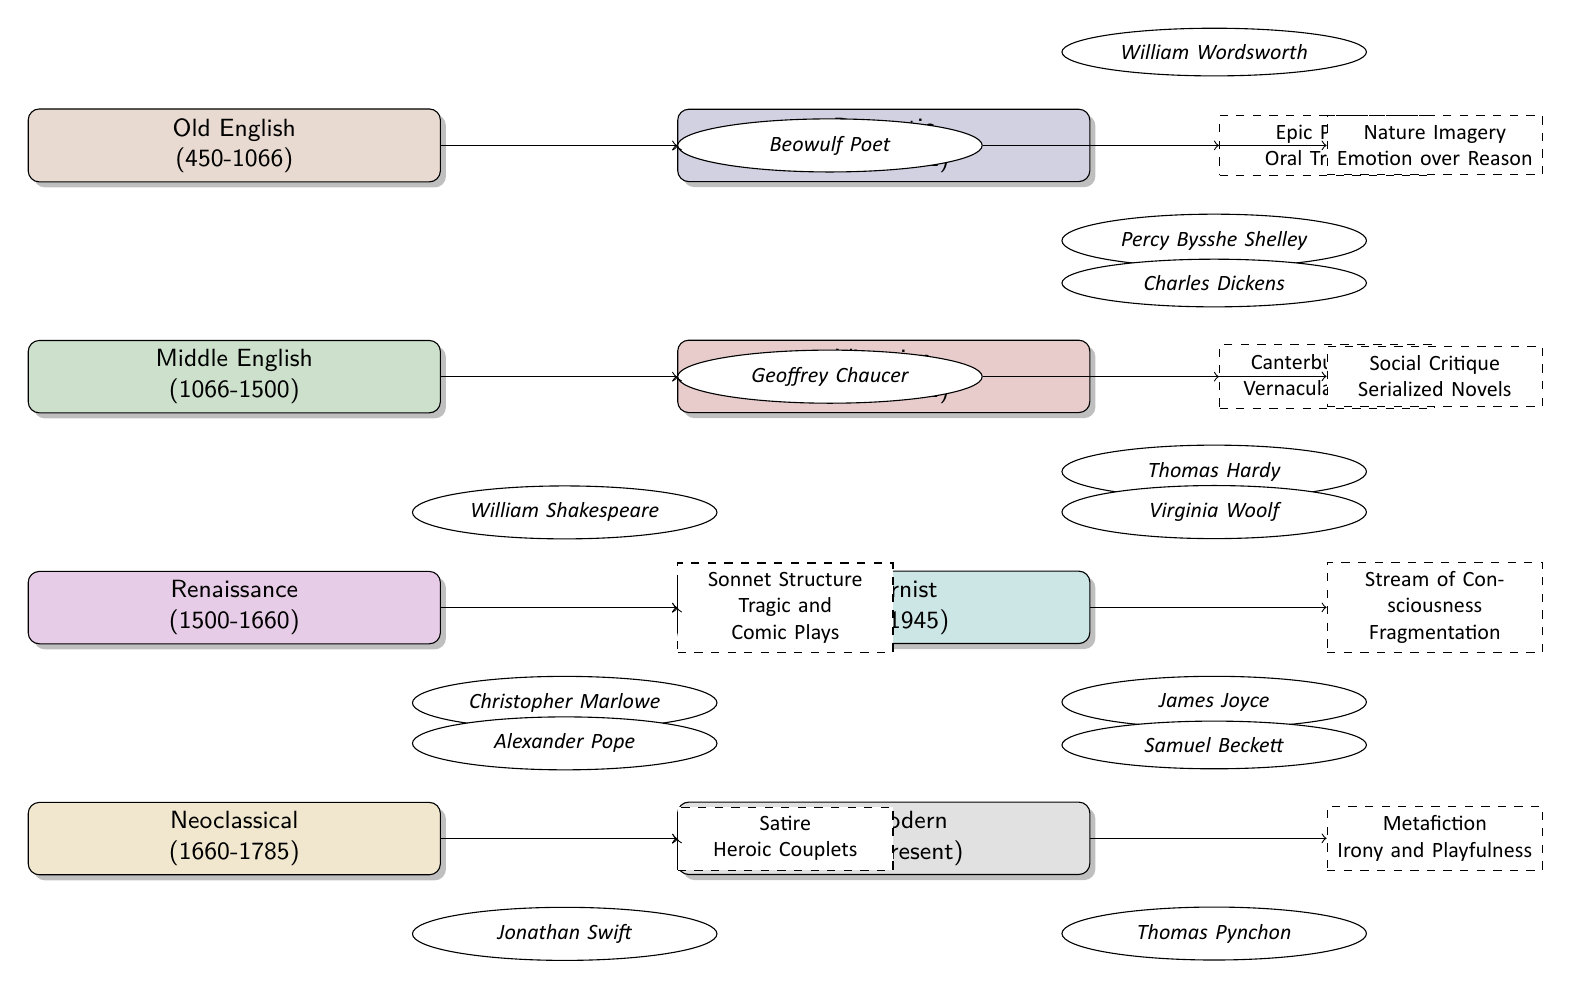What is the time period for the Renaissance? In the diagram, the Renaissance period is indicated as lasting from 1500 to 1660, which is situated below the Middle English section.
Answer: 1500-1660 Who is associated with the contribution of "Social Critique"? The diagram shows that both Charles Dickens and Thomas Hardy are linked to the Victorian period, which has the contribution of "Social Critique" connected to it.
Answer: Charles Dickens and Thomas Hardy How many literary periods are depicted in the diagram? By counting each labeled rectangle representing a period, we find there are eight literary periods illustrated in the diagram, from Old English to Postmodern.
Answer: 8 Which author is linked to the contribution of "Stream of Consciousness"? The Modernist period, indicated on the diagram, features authors Virginia Woolf and James Joyce, both of whom contribute to the idea of "Stream of Consciousness."
Answer: Virginia Woolf and James Joyce Which literary period is represented immediately after the Victorian period? The diagram places the Modernist period directly under the Victorian period, indicating the sequential evolution of literary periods.
Answer: Modernist What is the primary characteristic of the Romantic period? According to the diagram, the Romantic period's primary characteristic is depicted as focusing on "Nature Imagery" and emphasizing "Emotion over Reason."
Answer: Nature Imagery and Emotion over Reason How does "Metafiction" relate to the Postmodern period? The Postmodern period in the diagram specifically lists "Metafiction" as one of its notable contributions, highlighted along with authors such as Samuel Beckett and Thomas Pynchon.
Answer: Metafiction Which two authors contributed to the Renaissance period? The Renaissance period in the diagram features both William Shakespeare and Christopher Marlowe, who are linked to its contributions related to plays and sonnet structure.
Answer: William Shakespeare and Christopher Marlowe 